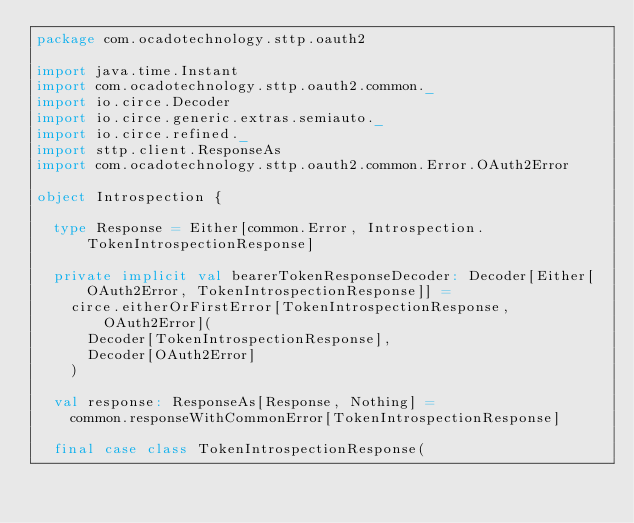Convert code to text. <code><loc_0><loc_0><loc_500><loc_500><_Scala_>package com.ocadotechnology.sttp.oauth2

import java.time.Instant
import com.ocadotechnology.sttp.oauth2.common._
import io.circe.Decoder
import io.circe.generic.extras.semiauto._
import io.circe.refined._
import sttp.client.ResponseAs
import com.ocadotechnology.sttp.oauth2.common.Error.OAuth2Error

object Introspection {

  type Response = Either[common.Error, Introspection.TokenIntrospectionResponse]

  private implicit val bearerTokenResponseDecoder: Decoder[Either[OAuth2Error, TokenIntrospectionResponse]] =
    circe.eitherOrFirstError[TokenIntrospectionResponse, OAuth2Error](
      Decoder[TokenIntrospectionResponse],
      Decoder[OAuth2Error]
    )

  val response: ResponseAs[Response, Nothing] =
    common.responseWithCommonError[TokenIntrospectionResponse]

  final case class TokenIntrospectionResponse(</code> 